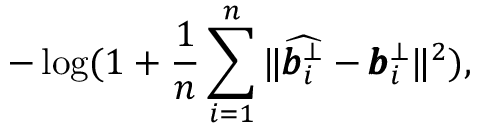<formula> <loc_0><loc_0><loc_500><loc_500>- \log ( 1 + \frac { 1 } { n } \sum _ { i = 1 } ^ { n } { \| \widehat { \pm b { b } _ { i } ^ { \bot } } - \pm b { b } _ { i } ^ { \bot } \| ^ { 2 } } ) ,</formula> 